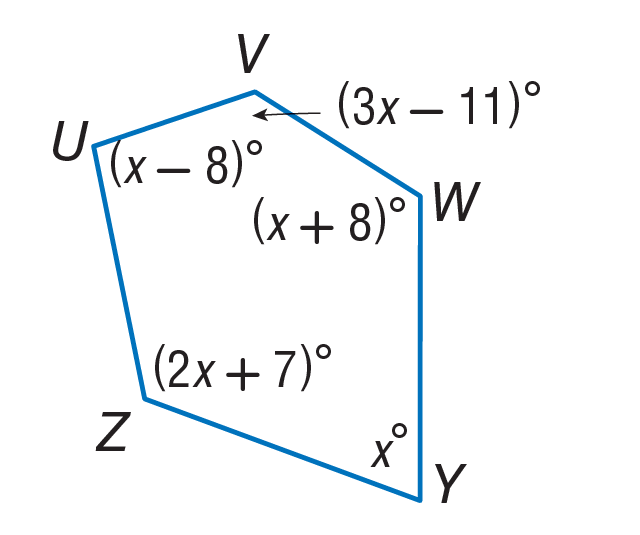Answer the mathemtical geometry problem and directly provide the correct option letter.
Question: Find m \angle Y.
Choices: A: 34 B: 68 C: 70 D: 136 B 